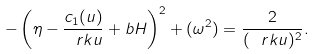<formula> <loc_0><loc_0><loc_500><loc_500>- \left ( \eta - \frac { c _ { 1 } ( u ) } { \ r k u } + b H \right ) ^ { 2 } + ( \omega ^ { 2 } ) = \frac { 2 } { ( \ r k u ) ^ { 2 } } .</formula> 